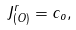<formula> <loc_0><loc_0><loc_500><loc_500>J ^ { r } _ { ( O ) } = c _ { o } ,</formula> 